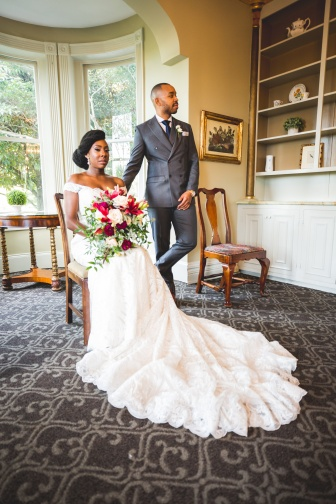Analyze the image in a comprehensive and detailed manner. In the image, there is a bride and groom captured in a moment of serene intimacy in an elegantly decorated room. The bride is seated on a wooden chair, wearing a stunning white dress with a long, graceful train that spreads out beautifully on the gray carpet beneath her. She holds a vibrant bouquet of red and white flowers in her lap, adding a splash of color to the serene scene.

The groom stands behind her, dressed in a sophisticated gray suit, looking at her with a tender expression. The room is decorated in a classic style, featuring white walls and a gray patterned carpet. A large window to the side allows natural light to flood the space, highlighting the couple and casting a warm glow throughout the room.

Behind them, there are two more wooden chairs and a wooden table, suggesting a space for guests or a place for the couple to share intimate moments. A bookcase stands against one wall, with a few decorative items and plenty of space for books or personal mementos. Overall, the image perfectly captures a poignant and beautiful moment between the bride and groom, set against a backdrop of elegance and simplicity. 